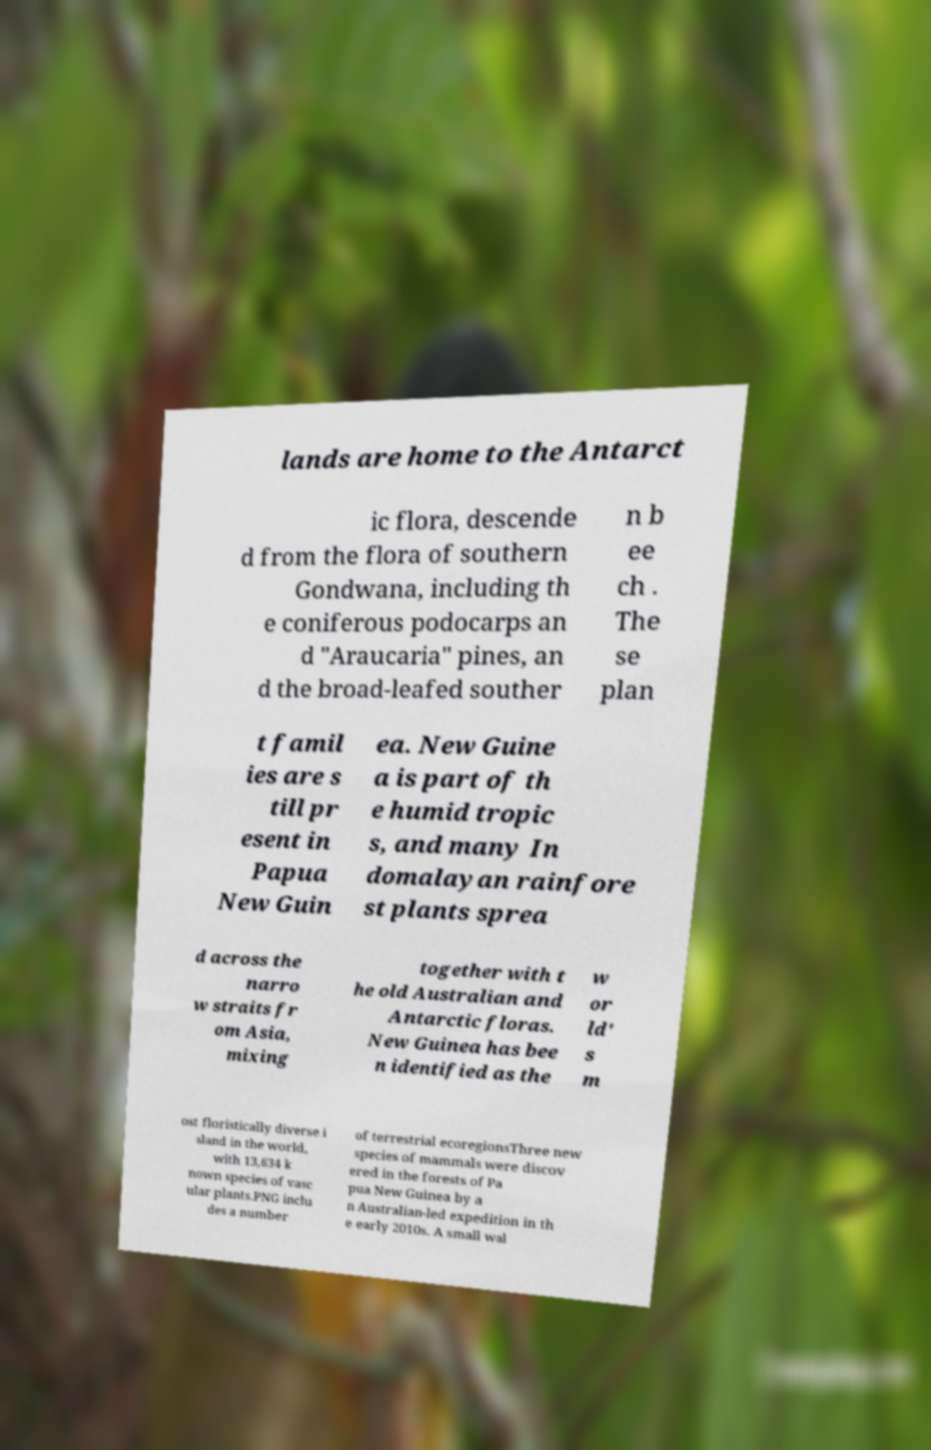What messages or text are displayed in this image? I need them in a readable, typed format. lands are home to the Antarct ic flora, descende d from the flora of southern Gondwana, including th e coniferous podocarps an d "Araucaria" pines, an d the broad-leafed souther n b ee ch . The se plan t famil ies are s till pr esent in Papua New Guin ea. New Guine a is part of th e humid tropic s, and many In domalayan rainfore st plants sprea d across the narro w straits fr om Asia, mixing together with t he old Australian and Antarctic floras. New Guinea has bee n identified as the w or ld' s m ost floristically diverse i sland in the world, with 13,634 k nown species of vasc ular plants.PNG inclu des a number of terrestrial ecoregionsThree new species of mammals were discov ered in the forests of Pa pua New Guinea by a n Australian-led expedition in th e early 2010s. A small wal 